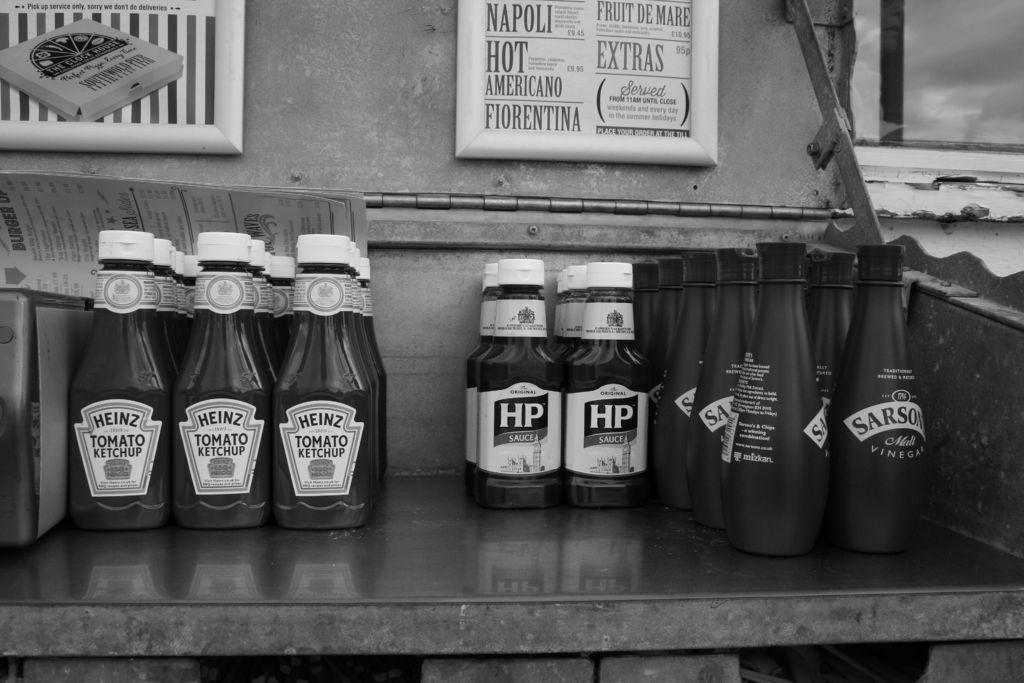Please provide a concise description of this image. In the image in the center we can see some bottles. On the left side bottles it was named as "Tomato Ketchup". And coming to the between bottled it is named has "Hp". And coming to the right side bottle it is named as "Sargon". And coming to the background we can see frame and wall. 